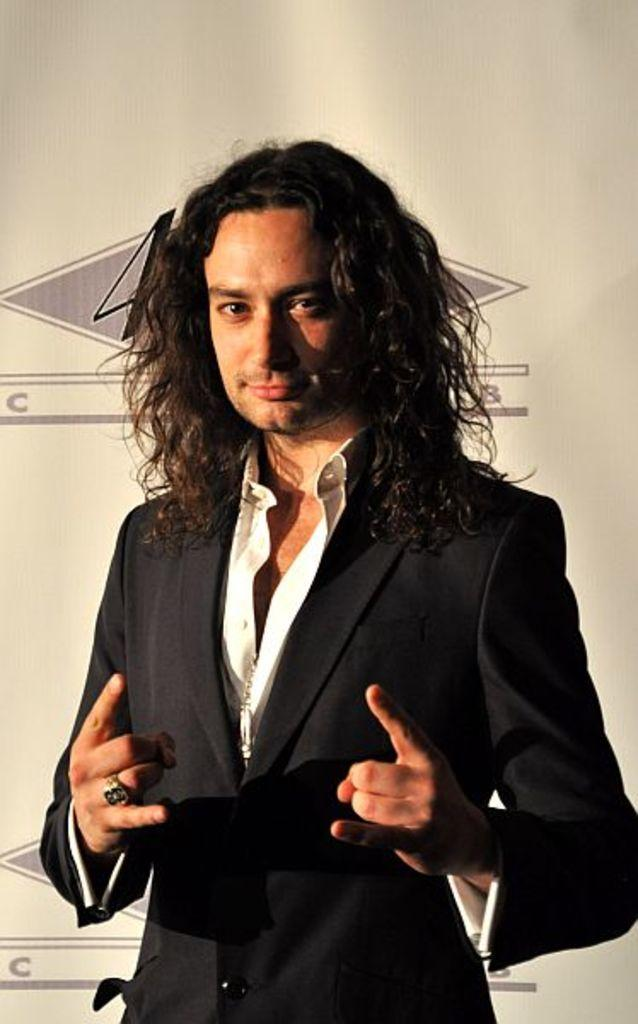What is the main subject of the image? The main subject of the image is a man. What is the man wearing in the image? The man is wearing a blazer. What is the man doing in the image? The man is standing in the image. What is the man's facial expression in the image? The man is smiling in the image. Where is the drain located in the image? There is no drain present in the image. What type of meeting is taking place in the image? There is no meeting taking place in the image; it only features a man standing and smiling. 